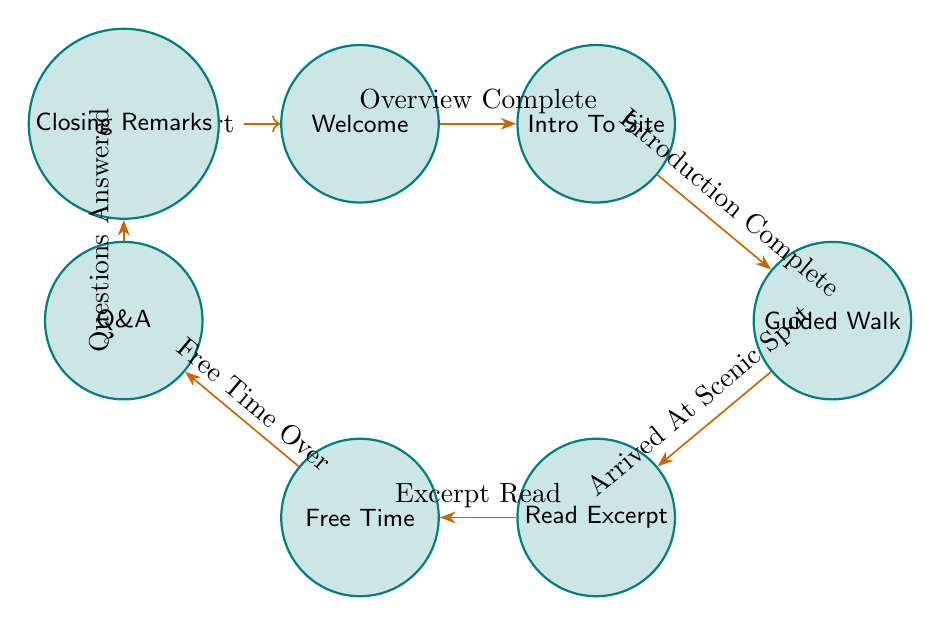What is the initial state of the diagram? The diagram starts at the "Welcome" state, which is marked as the initial state in the finite state machine structure.
Answer: Welcome How many states are in the diagram? By counting the states listed, there are a total of 7 states in the diagram: Welcome, IntroToSite, GuidedWalk, ReadExcerpt, FreeTime, QandA, and ClosingRemarks.
Answer: 7 What is the transition from the "FreeTime" state? The state "FreeTime" transitions to "QandA" when the trigger "Free Time Over" occurs, as indicated by the directed edge in the diagram.
Answer: QandA What is the trigger for moving from "GuidedWalk" to "ReadExcerpt"? The transition from "GuidedWalk" to "ReadExcerpt" occurs when the "Arrived At Scenic Spot" trigger is activated, as reflected in the diagram's flow.
Answer: Arrived At Scenic Spot Identify one key connection between the "IntroToSite" and "GuidedWalk" states. The key connection is that the transition from "IntroToSite" to "GuidedWalk" is triggered by "Introduction Complete," which indicates a sequential flow in the tour process.
Answer: Introduction Complete How does the tour conclude? The tour concludes by transitioning from the "QandA" state to "ClosingRemarks" state triggered by "Questions Answered," summarizing the tour before farewells.
Answer: ClosingRemarks What comes after the "ReadExcerpt"? Following "ReadExcerpt," the next state in the sequence is "FreeTime," which suggests guests can explore freely after the excerpt is read.
Answer: FreeTime What is the relationship between the "Welcome" and "ClosingRemarks" states? The relationship is that both states are endpoints in the flow of the tour; "Welcome" is the beginning while "ClosingRemarks" is the final state, with a series of transitions connecting them through the tour narrative.
Answer: Sequential flow 